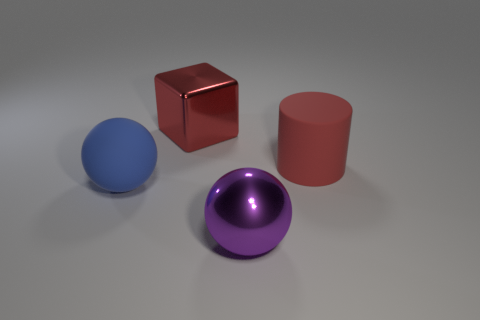Add 2 small red cubes. How many objects exist? 6 Add 3 big purple shiny spheres. How many big purple shiny spheres are left? 4 Add 1 large red objects. How many large red objects exist? 3 Subtract 0 green cubes. How many objects are left? 4 Subtract all red shiny blocks. Subtract all objects. How many objects are left? 2 